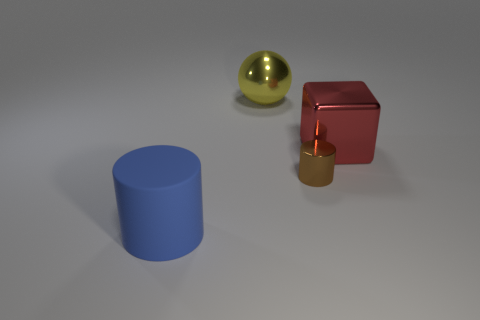What is the material of the big thing behind the thing that is right of the cylinder that is behind the blue thing?
Ensure brevity in your answer.  Metal. Does the thing behind the shiny block have the same size as the blue rubber object?
Provide a succinct answer. Yes. Is the number of red objects greater than the number of big objects?
Your answer should be compact. No. What number of small things are either red blocks or blue cylinders?
Provide a short and direct response. 0. What number of other things are the same color as the big cylinder?
Offer a terse response. 0. How many small brown cylinders are the same material as the big yellow object?
Your answer should be compact. 1. There is a cylinder behind the large rubber cylinder; is it the same color as the ball?
Offer a terse response. No. What number of blue objects are metal cylinders or large rubber objects?
Your answer should be very brief. 1. Is there any other thing that is the same material as the big blue object?
Provide a short and direct response. No. Is the material of the big object that is right of the tiny brown metal cylinder the same as the blue cylinder?
Offer a very short reply. No. 